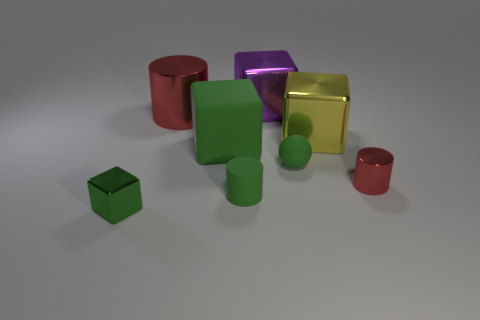Add 2 yellow metal blocks. How many objects exist? 10 Subtract all green rubber blocks. How many blocks are left? 3 Subtract all red cylinders. How many cylinders are left? 1 Subtract 1 cubes. How many cubes are left? 3 Subtract all cylinders. How many objects are left? 5 Subtract all brown spheres. Subtract all red cylinders. How many spheres are left? 1 Subtract all cyan blocks. How many yellow balls are left? 0 Subtract all big green blocks. Subtract all big green matte things. How many objects are left? 6 Add 6 tiny blocks. How many tiny blocks are left? 7 Add 4 balls. How many balls exist? 5 